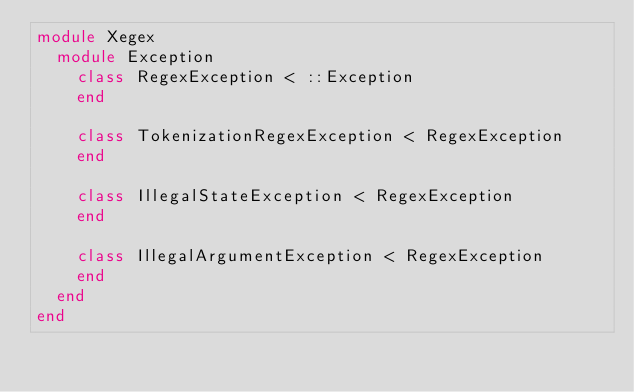Convert code to text. <code><loc_0><loc_0><loc_500><loc_500><_Crystal_>module Xegex
  module Exception
    class RegexException < ::Exception
    end

    class TokenizationRegexException < RegexException
    end

    class IllegalStateException < RegexException
    end

    class IllegalArgumentException < RegexException
    end
  end
end
</code> 